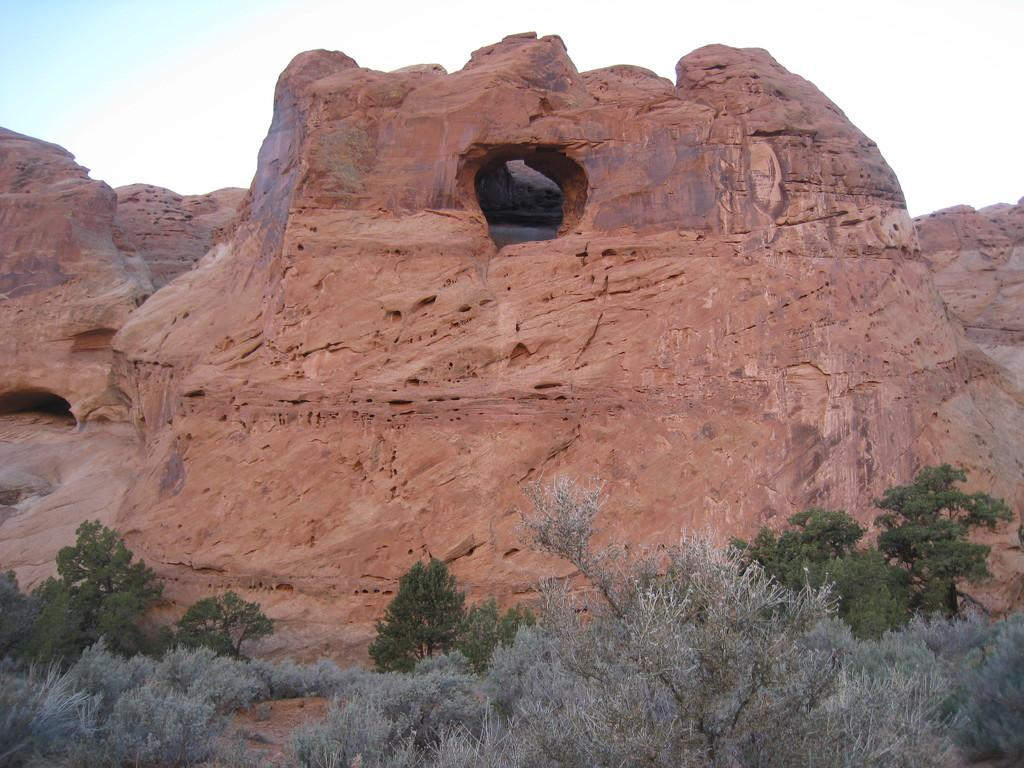What is the main feature in the center of the image? There is a cave in the center of the image. What type of vegetation can be seen at the bottom of the image? There are trees at the bottom of the image. What type of voice can be heard coming from the cave in the image? There is no indication of any sound or voice in the image, as it only shows a cave and trees. 